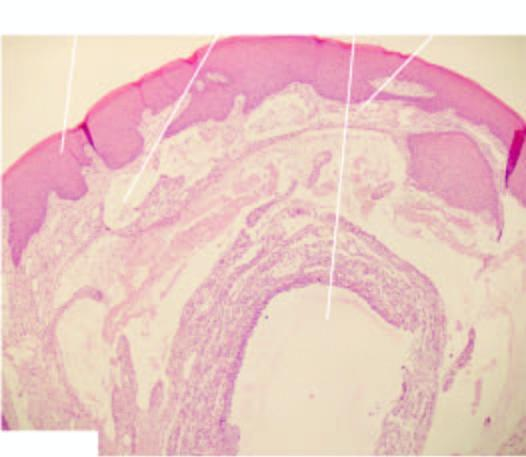what is there?
Answer the question using a single word or phrase. Inflammatory reaction around extravasated mucus 